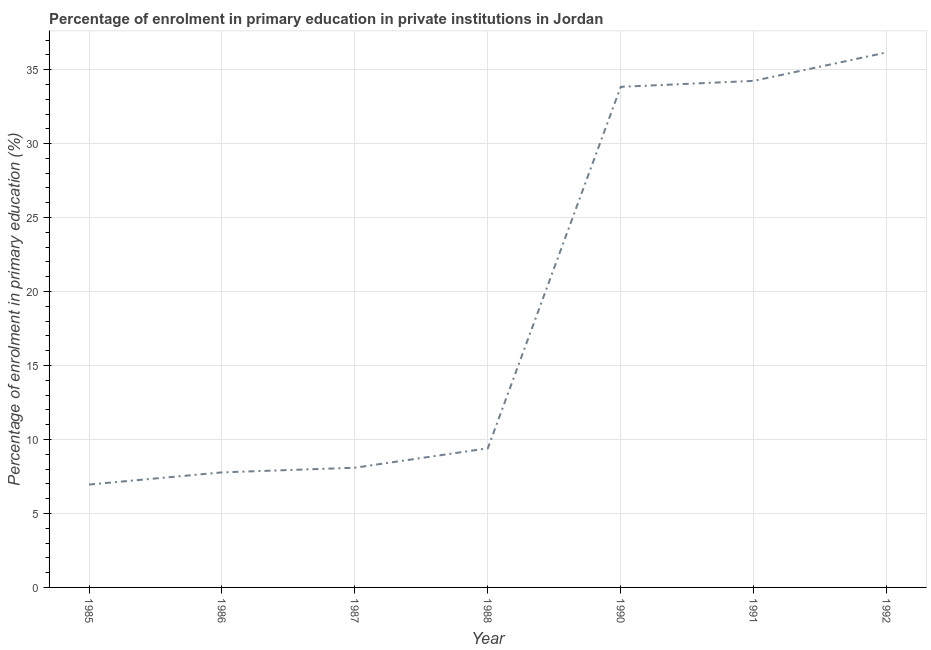What is the enrolment percentage in primary education in 1985?
Your answer should be compact. 6.95. Across all years, what is the maximum enrolment percentage in primary education?
Make the answer very short. 36.16. Across all years, what is the minimum enrolment percentage in primary education?
Your response must be concise. 6.95. What is the sum of the enrolment percentage in primary education?
Ensure brevity in your answer.  136.47. What is the difference between the enrolment percentage in primary education in 1987 and 1988?
Ensure brevity in your answer.  -1.31. What is the average enrolment percentage in primary education per year?
Give a very brief answer. 19.5. What is the median enrolment percentage in primary education?
Offer a terse response. 9.4. Do a majority of the years between 1986 and 1992 (inclusive) have enrolment percentage in primary education greater than 35 %?
Keep it short and to the point. No. What is the ratio of the enrolment percentage in primary education in 1985 to that in 1987?
Provide a short and direct response. 0.86. Is the difference between the enrolment percentage in primary education in 1990 and 1991 greater than the difference between any two years?
Your response must be concise. No. What is the difference between the highest and the second highest enrolment percentage in primary education?
Offer a terse response. 1.92. What is the difference between the highest and the lowest enrolment percentage in primary education?
Ensure brevity in your answer.  29.21. In how many years, is the enrolment percentage in primary education greater than the average enrolment percentage in primary education taken over all years?
Make the answer very short. 3. How many lines are there?
Keep it short and to the point. 1. How many years are there in the graph?
Provide a succinct answer. 7. What is the difference between two consecutive major ticks on the Y-axis?
Ensure brevity in your answer.  5. Are the values on the major ticks of Y-axis written in scientific E-notation?
Your answer should be compact. No. Does the graph contain grids?
Make the answer very short. Yes. What is the title of the graph?
Offer a terse response. Percentage of enrolment in primary education in private institutions in Jordan. What is the label or title of the Y-axis?
Make the answer very short. Percentage of enrolment in primary education (%). What is the Percentage of enrolment in primary education (%) of 1985?
Offer a terse response. 6.95. What is the Percentage of enrolment in primary education (%) of 1986?
Your response must be concise. 7.78. What is the Percentage of enrolment in primary education (%) in 1987?
Your response must be concise. 8.09. What is the Percentage of enrolment in primary education (%) of 1988?
Your response must be concise. 9.4. What is the Percentage of enrolment in primary education (%) in 1990?
Keep it short and to the point. 33.84. What is the Percentage of enrolment in primary education (%) in 1991?
Offer a very short reply. 34.24. What is the Percentage of enrolment in primary education (%) of 1992?
Offer a very short reply. 36.16. What is the difference between the Percentage of enrolment in primary education (%) in 1985 and 1986?
Provide a succinct answer. -0.82. What is the difference between the Percentage of enrolment in primary education (%) in 1985 and 1987?
Provide a succinct answer. -1.14. What is the difference between the Percentage of enrolment in primary education (%) in 1985 and 1988?
Your answer should be compact. -2.45. What is the difference between the Percentage of enrolment in primary education (%) in 1985 and 1990?
Provide a succinct answer. -26.88. What is the difference between the Percentage of enrolment in primary education (%) in 1985 and 1991?
Your answer should be very brief. -27.29. What is the difference between the Percentage of enrolment in primary education (%) in 1985 and 1992?
Ensure brevity in your answer.  -29.21. What is the difference between the Percentage of enrolment in primary education (%) in 1986 and 1987?
Offer a very short reply. -0.32. What is the difference between the Percentage of enrolment in primary education (%) in 1986 and 1988?
Provide a succinct answer. -1.63. What is the difference between the Percentage of enrolment in primary education (%) in 1986 and 1990?
Ensure brevity in your answer.  -26.06. What is the difference between the Percentage of enrolment in primary education (%) in 1986 and 1991?
Provide a succinct answer. -26.46. What is the difference between the Percentage of enrolment in primary education (%) in 1986 and 1992?
Offer a terse response. -28.39. What is the difference between the Percentage of enrolment in primary education (%) in 1987 and 1988?
Offer a very short reply. -1.31. What is the difference between the Percentage of enrolment in primary education (%) in 1987 and 1990?
Ensure brevity in your answer.  -25.75. What is the difference between the Percentage of enrolment in primary education (%) in 1987 and 1991?
Provide a short and direct response. -26.15. What is the difference between the Percentage of enrolment in primary education (%) in 1987 and 1992?
Your answer should be compact. -28.07. What is the difference between the Percentage of enrolment in primary education (%) in 1988 and 1990?
Ensure brevity in your answer.  -24.43. What is the difference between the Percentage of enrolment in primary education (%) in 1988 and 1991?
Offer a terse response. -24.84. What is the difference between the Percentage of enrolment in primary education (%) in 1988 and 1992?
Provide a short and direct response. -26.76. What is the difference between the Percentage of enrolment in primary education (%) in 1990 and 1991?
Offer a very short reply. -0.4. What is the difference between the Percentage of enrolment in primary education (%) in 1990 and 1992?
Ensure brevity in your answer.  -2.33. What is the difference between the Percentage of enrolment in primary education (%) in 1991 and 1992?
Offer a terse response. -1.92. What is the ratio of the Percentage of enrolment in primary education (%) in 1985 to that in 1986?
Your answer should be very brief. 0.89. What is the ratio of the Percentage of enrolment in primary education (%) in 1985 to that in 1987?
Give a very brief answer. 0.86. What is the ratio of the Percentage of enrolment in primary education (%) in 1985 to that in 1988?
Offer a terse response. 0.74. What is the ratio of the Percentage of enrolment in primary education (%) in 1985 to that in 1990?
Offer a very short reply. 0.21. What is the ratio of the Percentage of enrolment in primary education (%) in 1985 to that in 1991?
Offer a very short reply. 0.2. What is the ratio of the Percentage of enrolment in primary education (%) in 1985 to that in 1992?
Your answer should be very brief. 0.19. What is the ratio of the Percentage of enrolment in primary education (%) in 1986 to that in 1988?
Provide a short and direct response. 0.83. What is the ratio of the Percentage of enrolment in primary education (%) in 1986 to that in 1990?
Offer a terse response. 0.23. What is the ratio of the Percentage of enrolment in primary education (%) in 1986 to that in 1991?
Offer a terse response. 0.23. What is the ratio of the Percentage of enrolment in primary education (%) in 1986 to that in 1992?
Provide a short and direct response. 0.21. What is the ratio of the Percentage of enrolment in primary education (%) in 1987 to that in 1988?
Provide a short and direct response. 0.86. What is the ratio of the Percentage of enrolment in primary education (%) in 1987 to that in 1990?
Make the answer very short. 0.24. What is the ratio of the Percentage of enrolment in primary education (%) in 1987 to that in 1991?
Ensure brevity in your answer.  0.24. What is the ratio of the Percentage of enrolment in primary education (%) in 1987 to that in 1992?
Provide a short and direct response. 0.22. What is the ratio of the Percentage of enrolment in primary education (%) in 1988 to that in 1990?
Keep it short and to the point. 0.28. What is the ratio of the Percentage of enrolment in primary education (%) in 1988 to that in 1991?
Keep it short and to the point. 0.28. What is the ratio of the Percentage of enrolment in primary education (%) in 1988 to that in 1992?
Your answer should be compact. 0.26. What is the ratio of the Percentage of enrolment in primary education (%) in 1990 to that in 1991?
Make the answer very short. 0.99. What is the ratio of the Percentage of enrolment in primary education (%) in 1990 to that in 1992?
Your response must be concise. 0.94. What is the ratio of the Percentage of enrolment in primary education (%) in 1991 to that in 1992?
Ensure brevity in your answer.  0.95. 